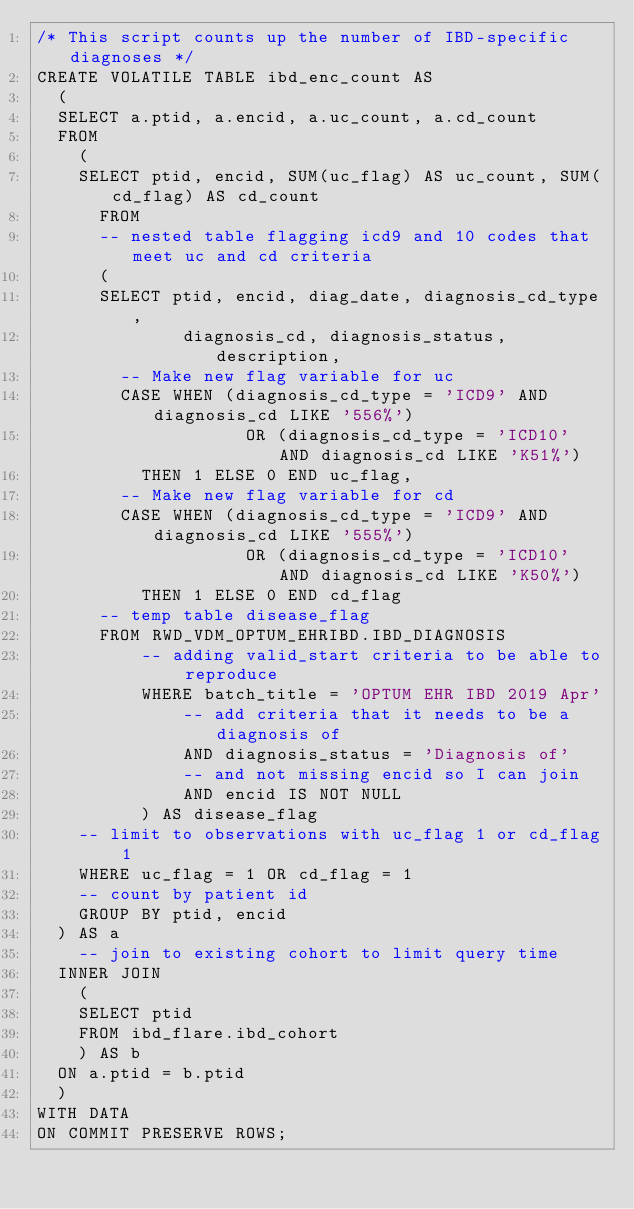Convert code to text. <code><loc_0><loc_0><loc_500><loc_500><_SQL_>/* This script counts up the number of IBD-specific diagnoses */
CREATE VOLATILE TABLE ibd_enc_count AS
	(
	SELECT a.ptid, a.encid, a.uc_count, a.cd_count 
	FROM 
		(
		SELECT ptid, encid, SUM(uc_flag) AS uc_count, SUM(cd_flag) AS cd_count
			FROM
			-- nested table flagging icd9 and 10 codes that meet uc and cd criteria
			(
			SELECT ptid, encid, diag_date, diagnosis_cd_type, 
	            diagnosis_cd, diagnosis_status, description,
				-- Make new flag variable for uc
				CASE WHEN (diagnosis_cd_type = 'ICD9' AND diagnosis_cd LIKE '556%') 
                    OR (diagnosis_cd_type = 'ICD10' AND diagnosis_cd LIKE 'K51%')
					THEN 1 ELSE 0 END uc_flag,
				-- Make new flag variable for cd
				CASE WHEN (diagnosis_cd_type = 'ICD9' AND diagnosis_cd LIKE '555%') 
                    OR (diagnosis_cd_type = 'ICD10' AND diagnosis_cd LIKE 'K50%')
					THEN 1 ELSE 0 END cd_flag
			-- temp table disease_flag
			FROM RWD_VDM_OPTUM_EHRIBD.IBD_DIAGNOSIS
	        -- adding valid_start criteria to be able to reproduce
	        WHERE batch_title = 'OPTUM EHR IBD 2019 Apr' 
	            -- add criteria that it needs to be a diagnosis of
	            AND diagnosis_status = 'Diagnosis of'
	            -- and not missing encid so I can join
	            AND encid IS NOT NULL
	        ) AS disease_flag
		-- limit to observations with uc_flag 1 or cd_flag 1
		WHERE uc_flag = 1 OR cd_flag = 1
		-- count by patient id
		GROUP BY ptid, encid
	) AS a 
    -- join to existing cohort to limit query time
	INNER JOIN
		(
		SELECT ptid 
		FROM ibd_flare.ibd_cohort
		) AS b
	ON a.ptid = b.ptid
	) 
WITH DATA
ON COMMIT PRESERVE ROWS;
</code> 